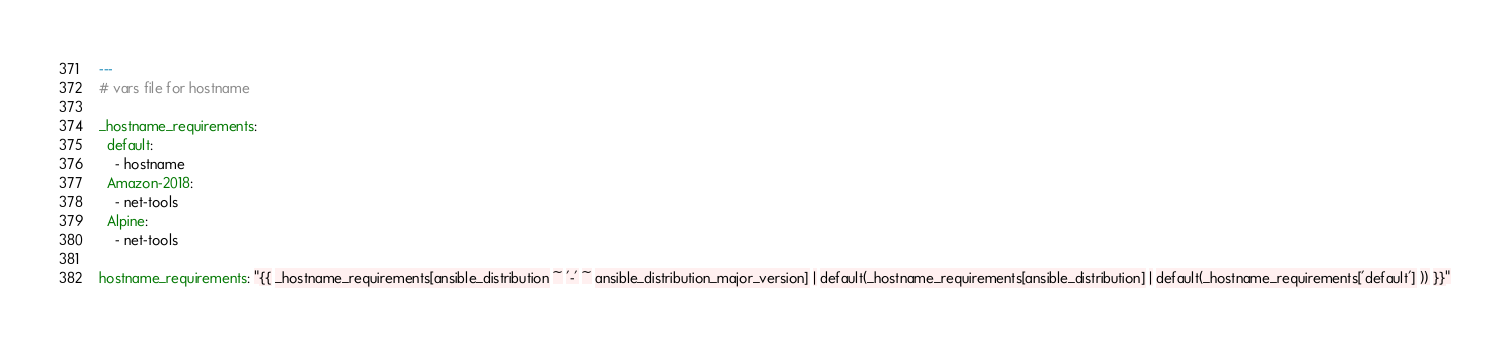<code> <loc_0><loc_0><loc_500><loc_500><_YAML_>---
# vars file for hostname

_hostname_requirements:
  default:
    - hostname
  Amazon-2018:
    - net-tools
  Alpine:
    - net-tools

hostname_requirements: "{{ _hostname_requirements[ansible_distribution ~ '-' ~ ansible_distribution_major_version] | default(_hostname_requirements[ansible_distribution] | default(_hostname_requirements['default'] )) }}"
</code> 